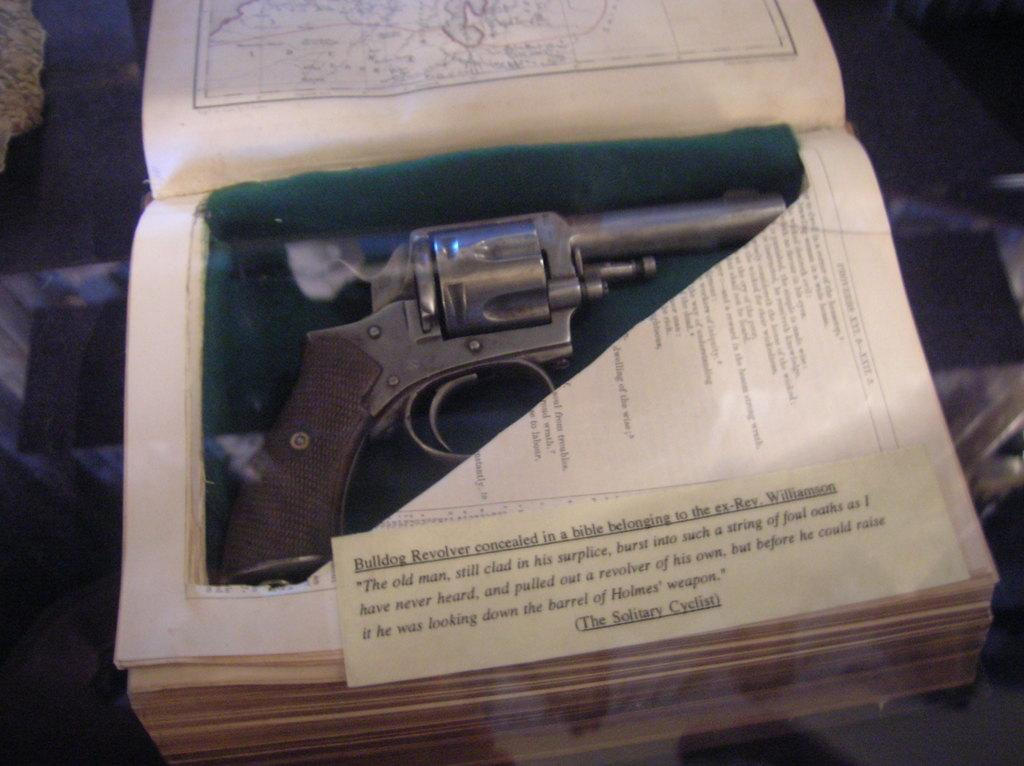What object is present in the book in the image? There is a gun in the book in the image. What can be found on the papers in the image? There is text on the papers in the image. What type of journey is depicted in the image? There is no journey depicted in the image; it features a book with a gun and papers with text. 